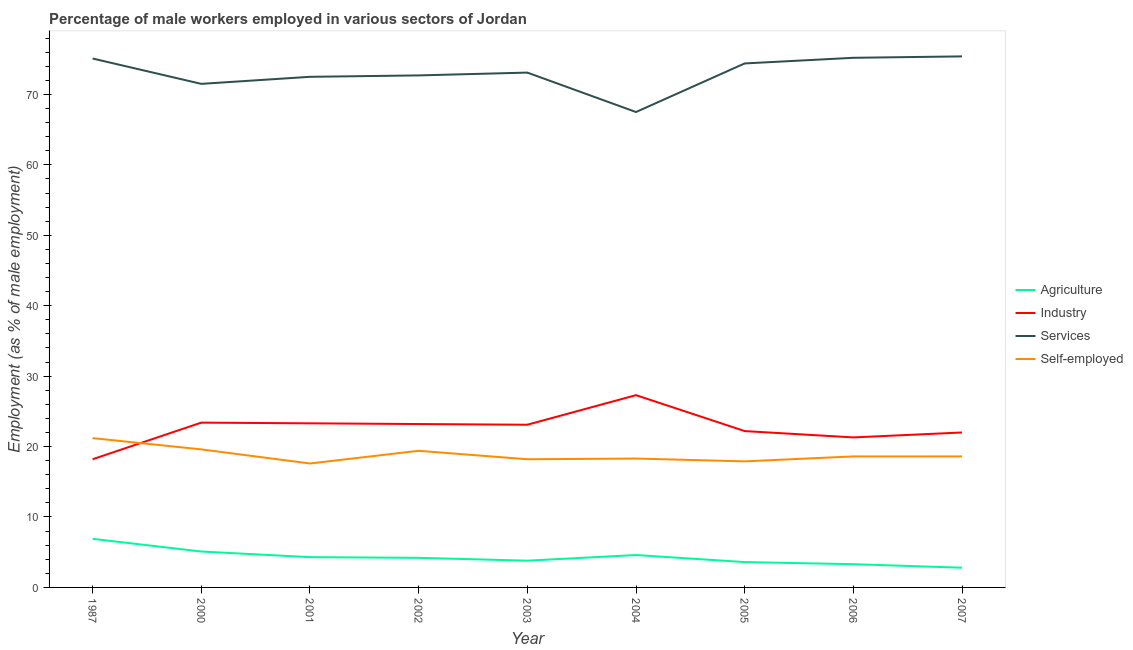How many different coloured lines are there?
Provide a short and direct response. 4. Does the line corresponding to percentage of male workers in industry intersect with the line corresponding to percentage of male workers in agriculture?
Provide a short and direct response. No. What is the percentage of male workers in services in 2000?
Ensure brevity in your answer.  71.5. Across all years, what is the maximum percentage of male workers in services?
Give a very brief answer. 75.4. Across all years, what is the minimum percentage of male workers in agriculture?
Keep it short and to the point. 2.8. In which year was the percentage of male workers in industry maximum?
Your answer should be very brief. 2004. What is the total percentage of male workers in agriculture in the graph?
Your answer should be very brief. 38.6. What is the difference between the percentage of self employed male workers in 2002 and that in 2007?
Keep it short and to the point. 0.8. What is the difference between the percentage of male workers in agriculture in 2002 and the percentage of male workers in industry in 2004?
Provide a succinct answer. -23.1. What is the average percentage of male workers in industry per year?
Make the answer very short. 22.67. In the year 2005, what is the difference between the percentage of male workers in industry and percentage of male workers in services?
Provide a short and direct response. -52.2. In how many years, is the percentage of self employed male workers greater than 72 %?
Ensure brevity in your answer.  0. What is the ratio of the percentage of male workers in agriculture in 2003 to that in 2004?
Your answer should be compact. 0.83. Is the difference between the percentage of self employed male workers in 1987 and 2000 greater than the difference between the percentage of male workers in agriculture in 1987 and 2000?
Provide a short and direct response. No. What is the difference between the highest and the second highest percentage of male workers in industry?
Your answer should be compact. 3.9. What is the difference between the highest and the lowest percentage of male workers in industry?
Your answer should be very brief. 9.1. Is it the case that in every year, the sum of the percentage of male workers in agriculture and percentage of self employed male workers is greater than the sum of percentage of male workers in services and percentage of male workers in industry?
Your answer should be compact. Yes. How many years are there in the graph?
Your answer should be very brief. 9. Are the values on the major ticks of Y-axis written in scientific E-notation?
Make the answer very short. No. Does the graph contain any zero values?
Provide a short and direct response. No. Does the graph contain grids?
Make the answer very short. No. How many legend labels are there?
Offer a terse response. 4. How are the legend labels stacked?
Provide a short and direct response. Vertical. What is the title of the graph?
Make the answer very short. Percentage of male workers employed in various sectors of Jordan. What is the label or title of the Y-axis?
Ensure brevity in your answer.  Employment (as % of male employment). What is the Employment (as % of male employment) in Agriculture in 1987?
Offer a very short reply. 6.9. What is the Employment (as % of male employment) of Industry in 1987?
Make the answer very short. 18.2. What is the Employment (as % of male employment) of Services in 1987?
Keep it short and to the point. 75.1. What is the Employment (as % of male employment) in Self-employed in 1987?
Your answer should be very brief. 21.2. What is the Employment (as % of male employment) of Agriculture in 2000?
Offer a terse response. 5.1. What is the Employment (as % of male employment) in Industry in 2000?
Your answer should be compact. 23.4. What is the Employment (as % of male employment) in Services in 2000?
Offer a terse response. 71.5. What is the Employment (as % of male employment) of Self-employed in 2000?
Make the answer very short. 19.6. What is the Employment (as % of male employment) in Agriculture in 2001?
Provide a succinct answer. 4.3. What is the Employment (as % of male employment) in Industry in 2001?
Make the answer very short. 23.3. What is the Employment (as % of male employment) of Services in 2001?
Offer a very short reply. 72.5. What is the Employment (as % of male employment) in Self-employed in 2001?
Make the answer very short. 17.6. What is the Employment (as % of male employment) of Agriculture in 2002?
Make the answer very short. 4.2. What is the Employment (as % of male employment) of Industry in 2002?
Your response must be concise. 23.2. What is the Employment (as % of male employment) in Services in 2002?
Give a very brief answer. 72.7. What is the Employment (as % of male employment) of Self-employed in 2002?
Your answer should be very brief. 19.4. What is the Employment (as % of male employment) in Agriculture in 2003?
Offer a terse response. 3.8. What is the Employment (as % of male employment) of Industry in 2003?
Provide a succinct answer. 23.1. What is the Employment (as % of male employment) in Services in 2003?
Make the answer very short. 73.1. What is the Employment (as % of male employment) in Self-employed in 2003?
Keep it short and to the point. 18.2. What is the Employment (as % of male employment) in Agriculture in 2004?
Your answer should be compact. 4.6. What is the Employment (as % of male employment) in Industry in 2004?
Your answer should be compact. 27.3. What is the Employment (as % of male employment) of Services in 2004?
Ensure brevity in your answer.  67.5. What is the Employment (as % of male employment) of Self-employed in 2004?
Give a very brief answer. 18.3. What is the Employment (as % of male employment) of Agriculture in 2005?
Give a very brief answer. 3.6. What is the Employment (as % of male employment) in Industry in 2005?
Give a very brief answer. 22.2. What is the Employment (as % of male employment) of Services in 2005?
Keep it short and to the point. 74.4. What is the Employment (as % of male employment) in Self-employed in 2005?
Provide a short and direct response. 17.9. What is the Employment (as % of male employment) of Agriculture in 2006?
Ensure brevity in your answer.  3.3. What is the Employment (as % of male employment) in Industry in 2006?
Offer a terse response. 21.3. What is the Employment (as % of male employment) of Services in 2006?
Your response must be concise. 75.2. What is the Employment (as % of male employment) of Self-employed in 2006?
Make the answer very short. 18.6. What is the Employment (as % of male employment) in Agriculture in 2007?
Your answer should be very brief. 2.8. What is the Employment (as % of male employment) in Industry in 2007?
Offer a terse response. 22. What is the Employment (as % of male employment) of Services in 2007?
Your answer should be very brief. 75.4. What is the Employment (as % of male employment) of Self-employed in 2007?
Your response must be concise. 18.6. Across all years, what is the maximum Employment (as % of male employment) in Agriculture?
Your answer should be very brief. 6.9. Across all years, what is the maximum Employment (as % of male employment) in Industry?
Your answer should be compact. 27.3. Across all years, what is the maximum Employment (as % of male employment) of Services?
Your answer should be very brief. 75.4. Across all years, what is the maximum Employment (as % of male employment) in Self-employed?
Ensure brevity in your answer.  21.2. Across all years, what is the minimum Employment (as % of male employment) of Agriculture?
Offer a very short reply. 2.8. Across all years, what is the minimum Employment (as % of male employment) of Industry?
Your answer should be very brief. 18.2. Across all years, what is the minimum Employment (as % of male employment) in Services?
Offer a very short reply. 67.5. Across all years, what is the minimum Employment (as % of male employment) in Self-employed?
Offer a terse response. 17.6. What is the total Employment (as % of male employment) of Agriculture in the graph?
Ensure brevity in your answer.  38.6. What is the total Employment (as % of male employment) of Industry in the graph?
Your answer should be very brief. 204. What is the total Employment (as % of male employment) of Services in the graph?
Make the answer very short. 657.4. What is the total Employment (as % of male employment) in Self-employed in the graph?
Make the answer very short. 169.4. What is the difference between the Employment (as % of male employment) of Industry in 1987 and that in 2000?
Offer a very short reply. -5.2. What is the difference between the Employment (as % of male employment) in Agriculture in 1987 and that in 2001?
Make the answer very short. 2.6. What is the difference between the Employment (as % of male employment) in Self-employed in 1987 and that in 2001?
Your answer should be very brief. 3.6. What is the difference between the Employment (as % of male employment) of Agriculture in 1987 and that in 2002?
Your response must be concise. 2.7. What is the difference between the Employment (as % of male employment) in Services in 1987 and that in 2002?
Offer a terse response. 2.4. What is the difference between the Employment (as % of male employment) in Self-employed in 1987 and that in 2002?
Keep it short and to the point. 1.8. What is the difference between the Employment (as % of male employment) in Agriculture in 1987 and that in 2003?
Offer a very short reply. 3.1. What is the difference between the Employment (as % of male employment) in Industry in 1987 and that in 2003?
Offer a very short reply. -4.9. What is the difference between the Employment (as % of male employment) of Self-employed in 1987 and that in 2003?
Ensure brevity in your answer.  3. What is the difference between the Employment (as % of male employment) of Industry in 1987 and that in 2004?
Keep it short and to the point. -9.1. What is the difference between the Employment (as % of male employment) in Services in 1987 and that in 2005?
Your answer should be compact. 0.7. What is the difference between the Employment (as % of male employment) in Self-employed in 1987 and that in 2005?
Offer a very short reply. 3.3. What is the difference between the Employment (as % of male employment) in Agriculture in 1987 and that in 2006?
Ensure brevity in your answer.  3.6. What is the difference between the Employment (as % of male employment) in Industry in 1987 and that in 2006?
Keep it short and to the point. -3.1. What is the difference between the Employment (as % of male employment) in Self-employed in 1987 and that in 2006?
Keep it short and to the point. 2.6. What is the difference between the Employment (as % of male employment) in Agriculture in 1987 and that in 2007?
Offer a terse response. 4.1. What is the difference between the Employment (as % of male employment) of Industry in 1987 and that in 2007?
Offer a very short reply. -3.8. What is the difference between the Employment (as % of male employment) of Services in 1987 and that in 2007?
Provide a short and direct response. -0.3. What is the difference between the Employment (as % of male employment) in Self-employed in 1987 and that in 2007?
Ensure brevity in your answer.  2.6. What is the difference between the Employment (as % of male employment) in Agriculture in 2000 and that in 2001?
Your answer should be compact. 0.8. What is the difference between the Employment (as % of male employment) in Services in 2000 and that in 2001?
Your response must be concise. -1. What is the difference between the Employment (as % of male employment) in Self-employed in 2000 and that in 2001?
Your answer should be compact. 2. What is the difference between the Employment (as % of male employment) in Agriculture in 2000 and that in 2002?
Offer a very short reply. 0.9. What is the difference between the Employment (as % of male employment) in Self-employed in 2000 and that in 2002?
Provide a short and direct response. 0.2. What is the difference between the Employment (as % of male employment) of Agriculture in 2000 and that in 2003?
Your response must be concise. 1.3. What is the difference between the Employment (as % of male employment) in Industry in 2000 and that in 2003?
Your response must be concise. 0.3. What is the difference between the Employment (as % of male employment) of Self-employed in 2000 and that in 2003?
Your answer should be very brief. 1.4. What is the difference between the Employment (as % of male employment) in Self-employed in 2000 and that in 2004?
Provide a succinct answer. 1.3. What is the difference between the Employment (as % of male employment) of Agriculture in 2000 and that in 2005?
Provide a succinct answer. 1.5. What is the difference between the Employment (as % of male employment) of Self-employed in 2000 and that in 2005?
Your response must be concise. 1.7. What is the difference between the Employment (as % of male employment) of Agriculture in 2000 and that in 2006?
Your answer should be compact. 1.8. What is the difference between the Employment (as % of male employment) in Agriculture in 2000 and that in 2007?
Your response must be concise. 2.3. What is the difference between the Employment (as % of male employment) of Industry in 2000 and that in 2007?
Provide a succinct answer. 1.4. What is the difference between the Employment (as % of male employment) in Services in 2000 and that in 2007?
Keep it short and to the point. -3.9. What is the difference between the Employment (as % of male employment) in Self-employed in 2000 and that in 2007?
Make the answer very short. 1. What is the difference between the Employment (as % of male employment) in Agriculture in 2001 and that in 2002?
Your answer should be very brief. 0.1. What is the difference between the Employment (as % of male employment) in Industry in 2001 and that in 2002?
Your answer should be very brief. 0.1. What is the difference between the Employment (as % of male employment) in Services in 2001 and that in 2002?
Make the answer very short. -0.2. What is the difference between the Employment (as % of male employment) in Self-employed in 2001 and that in 2002?
Offer a terse response. -1.8. What is the difference between the Employment (as % of male employment) of Industry in 2001 and that in 2003?
Provide a succinct answer. 0.2. What is the difference between the Employment (as % of male employment) in Self-employed in 2001 and that in 2003?
Your response must be concise. -0.6. What is the difference between the Employment (as % of male employment) in Agriculture in 2001 and that in 2004?
Provide a succinct answer. -0.3. What is the difference between the Employment (as % of male employment) in Services in 2001 and that in 2004?
Offer a terse response. 5. What is the difference between the Employment (as % of male employment) in Self-employed in 2001 and that in 2004?
Ensure brevity in your answer.  -0.7. What is the difference between the Employment (as % of male employment) of Agriculture in 2001 and that in 2006?
Ensure brevity in your answer.  1. What is the difference between the Employment (as % of male employment) in Services in 2001 and that in 2006?
Offer a terse response. -2.7. What is the difference between the Employment (as % of male employment) in Self-employed in 2001 and that in 2006?
Provide a short and direct response. -1. What is the difference between the Employment (as % of male employment) in Agriculture in 2001 and that in 2007?
Ensure brevity in your answer.  1.5. What is the difference between the Employment (as % of male employment) of Industry in 2001 and that in 2007?
Provide a short and direct response. 1.3. What is the difference between the Employment (as % of male employment) in Agriculture in 2002 and that in 2003?
Offer a very short reply. 0.4. What is the difference between the Employment (as % of male employment) of Services in 2002 and that in 2004?
Offer a very short reply. 5.2. What is the difference between the Employment (as % of male employment) in Self-employed in 2002 and that in 2004?
Keep it short and to the point. 1.1. What is the difference between the Employment (as % of male employment) of Industry in 2002 and that in 2005?
Your answer should be very brief. 1. What is the difference between the Employment (as % of male employment) of Self-employed in 2002 and that in 2005?
Make the answer very short. 1.5. What is the difference between the Employment (as % of male employment) of Agriculture in 2002 and that in 2006?
Your response must be concise. 0.9. What is the difference between the Employment (as % of male employment) of Industry in 2002 and that in 2006?
Your answer should be very brief. 1.9. What is the difference between the Employment (as % of male employment) in Services in 2002 and that in 2006?
Give a very brief answer. -2.5. What is the difference between the Employment (as % of male employment) in Self-employed in 2002 and that in 2006?
Keep it short and to the point. 0.8. What is the difference between the Employment (as % of male employment) of Agriculture in 2002 and that in 2007?
Your response must be concise. 1.4. What is the difference between the Employment (as % of male employment) of Industry in 2003 and that in 2005?
Your answer should be very brief. 0.9. What is the difference between the Employment (as % of male employment) of Services in 2003 and that in 2005?
Provide a short and direct response. -1.3. What is the difference between the Employment (as % of male employment) of Self-employed in 2003 and that in 2005?
Offer a very short reply. 0.3. What is the difference between the Employment (as % of male employment) in Industry in 2003 and that in 2006?
Offer a terse response. 1.8. What is the difference between the Employment (as % of male employment) of Self-employed in 2003 and that in 2007?
Provide a short and direct response. -0.4. What is the difference between the Employment (as % of male employment) of Agriculture in 2004 and that in 2005?
Keep it short and to the point. 1. What is the difference between the Employment (as % of male employment) of Industry in 2004 and that in 2005?
Make the answer very short. 5.1. What is the difference between the Employment (as % of male employment) of Services in 2004 and that in 2005?
Offer a terse response. -6.9. What is the difference between the Employment (as % of male employment) in Self-employed in 2004 and that in 2005?
Keep it short and to the point. 0.4. What is the difference between the Employment (as % of male employment) in Agriculture in 2004 and that in 2006?
Offer a very short reply. 1.3. What is the difference between the Employment (as % of male employment) of Industry in 2004 and that in 2006?
Offer a terse response. 6. What is the difference between the Employment (as % of male employment) in Services in 2004 and that in 2006?
Ensure brevity in your answer.  -7.7. What is the difference between the Employment (as % of male employment) of Self-employed in 2004 and that in 2006?
Offer a very short reply. -0.3. What is the difference between the Employment (as % of male employment) of Industry in 2004 and that in 2007?
Your answer should be compact. 5.3. What is the difference between the Employment (as % of male employment) of Services in 2004 and that in 2007?
Offer a terse response. -7.9. What is the difference between the Employment (as % of male employment) in Self-employed in 2004 and that in 2007?
Provide a short and direct response. -0.3. What is the difference between the Employment (as % of male employment) in Agriculture in 2005 and that in 2006?
Your answer should be very brief. 0.3. What is the difference between the Employment (as % of male employment) of Self-employed in 2005 and that in 2006?
Your answer should be very brief. -0.7. What is the difference between the Employment (as % of male employment) in Agriculture in 2005 and that in 2007?
Ensure brevity in your answer.  0.8. What is the difference between the Employment (as % of male employment) in Services in 2005 and that in 2007?
Your answer should be very brief. -1. What is the difference between the Employment (as % of male employment) of Self-employed in 2006 and that in 2007?
Provide a succinct answer. 0. What is the difference between the Employment (as % of male employment) in Agriculture in 1987 and the Employment (as % of male employment) in Industry in 2000?
Give a very brief answer. -16.5. What is the difference between the Employment (as % of male employment) in Agriculture in 1987 and the Employment (as % of male employment) in Services in 2000?
Make the answer very short. -64.6. What is the difference between the Employment (as % of male employment) of Industry in 1987 and the Employment (as % of male employment) of Services in 2000?
Offer a terse response. -53.3. What is the difference between the Employment (as % of male employment) of Industry in 1987 and the Employment (as % of male employment) of Self-employed in 2000?
Offer a terse response. -1.4. What is the difference between the Employment (as % of male employment) in Services in 1987 and the Employment (as % of male employment) in Self-employed in 2000?
Ensure brevity in your answer.  55.5. What is the difference between the Employment (as % of male employment) of Agriculture in 1987 and the Employment (as % of male employment) of Industry in 2001?
Offer a very short reply. -16.4. What is the difference between the Employment (as % of male employment) of Agriculture in 1987 and the Employment (as % of male employment) of Services in 2001?
Your response must be concise. -65.6. What is the difference between the Employment (as % of male employment) in Industry in 1987 and the Employment (as % of male employment) in Services in 2001?
Make the answer very short. -54.3. What is the difference between the Employment (as % of male employment) of Industry in 1987 and the Employment (as % of male employment) of Self-employed in 2001?
Provide a succinct answer. 0.6. What is the difference between the Employment (as % of male employment) of Services in 1987 and the Employment (as % of male employment) of Self-employed in 2001?
Give a very brief answer. 57.5. What is the difference between the Employment (as % of male employment) of Agriculture in 1987 and the Employment (as % of male employment) of Industry in 2002?
Your response must be concise. -16.3. What is the difference between the Employment (as % of male employment) of Agriculture in 1987 and the Employment (as % of male employment) of Services in 2002?
Offer a very short reply. -65.8. What is the difference between the Employment (as % of male employment) of Industry in 1987 and the Employment (as % of male employment) of Services in 2002?
Provide a succinct answer. -54.5. What is the difference between the Employment (as % of male employment) of Services in 1987 and the Employment (as % of male employment) of Self-employed in 2002?
Provide a short and direct response. 55.7. What is the difference between the Employment (as % of male employment) of Agriculture in 1987 and the Employment (as % of male employment) of Industry in 2003?
Your answer should be compact. -16.2. What is the difference between the Employment (as % of male employment) in Agriculture in 1987 and the Employment (as % of male employment) in Services in 2003?
Offer a terse response. -66.2. What is the difference between the Employment (as % of male employment) in Industry in 1987 and the Employment (as % of male employment) in Services in 2003?
Offer a terse response. -54.9. What is the difference between the Employment (as % of male employment) of Services in 1987 and the Employment (as % of male employment) of Self-employed in 2003?
Keep it short and to the point. 56.9. What is the difference between the Employment (as % of male employment) in Agriculture in 1987 and the Employment (as % of male employment) in Industry in 2004?
Give a very brief answer. -20.4. What is the difference between the Employment (as % of male employment) of Agriculture in 1987 and the Employment (as % of male employment) of Services in 2004?
Offer a terse response. -60.6. What is the difference between the Employment (as % of male employment) in Agriculture in 1987 and the Employment (as % of male employment) in Self-employed in 2004?
Keep it short and to the point. -11.4. What is the difference between the Employment (as % of male employment) of Industry in 1987 and the Employment (as % of male employment) of Services in 2004?
Provide a short and direct response. -49.3. What is the difference between the Employment (as % of male employment) in Services in 1987 and the Employment (as % of male employment) in Self-employed in 2004?
Provide a short and direct response. 56.8. What is the difference between the Employment (as % of male employment) in Agriculture in 1987 and the Employment (as % of male employment) in Industry in 2005?
Give a very brief answer. -15.3. What is the difference between the Employment (as % of male employment) of Agriculture in 1987 and the Employment (as % of male employment) of Services in 2005?
Ensure brevity in your answer.  -67.5. What is the difference between the Employment (as % of male employment) of Industry in 1987 and the Employment (as % of male employment) of Services in 2005?
Provide a short and direct response. -56.2. What is the difference between the Employment (as % of male employment) of Services in 1987 and the Employment (as % of male employment) of Self-employed in 2005?
Make the answer very short. 57.2. What is the difference between the Employment (as % of male employment) of Agriculture in 1987 and the Employment (as % of male employment) of Industry in 2006?
Provide a succinct answer. -14.4. What is the difference between the Employment (as % of male employment) in Agriculture in 1987 and the Employment (as % of male employment) in Services in 2006?
Your response must be concise. -68.3. What is the difference between the Employment (as % of male employment) in Agriculture in 1987 and the Employment (as % of male employment) in Self-employed in 2006?
Make the answer very short. -11.7. What is the difference between the Employment (as % of male employment) in Industry in 1987 and the Employment (as % of male employment) in Services in 2006?
Offer a terse response. -57. What is the difference between the Employment (as % of male employment) of Services in 1987 and the Employment (as % of male employment) of Self-employed in 2006?
Make the answer very short. 56.5. What is the difference between the Employment (as % of male employment) of Agriculture in 1987 and the Employment (as % of male employment) of Industry in 2007?
Provide a short and direct response. -15.1. What is the difference between the Employment (as % of male employment) in Agriculture in 1987 and the Employment (as % of male employment) in Services in 2007?
Your answer should be compact. -68.5. What is the difference between the Employment (as % of male employment) in Industry in 1987 and the Employment (as % of male employment) in Services in 2007?
Give a very brief answer. -57.2. What is the difference between the Employment (as % of male employment) of Services in 1987 and the Employment (as % of male employment) of Self-employed in 2007?
Give a very brief answer. 56.5. What is the difference between the Employment (as % of male employment) of Agriculture in 2000 and the Employment (as % of male employment) of Industry in 2001?
Offer a very short reply. -18.2. What is the difference between the Employment (as % of male employment) in Agriculture in 2000 and the Employment (as % of male employment) in Services in 2001?
Offer a terse response. -67.4. What is the difference between the Employment (as % of male employment) in Agriculture in 2000 and the Employment (as % of male employment) in Self-employed in 2001?
Your answer should be very brief. -12.5. What is the difference between the Employment (as % of male employment) in Industry in 2000 and the Employment (as % of male employment) in Services in 2001?
Your answer should be very brief. -49.1. What is the difference between the Employment (as % of male employment) of Industry in 2000 and the Employment (as % of male employment) of Self-employed in 2001?
Your answer should be compact. 5.8. What is the difference between the Employment (as % of male employment) of Services in 2000 and the Employment (as % of male employment) of Self-employed in 2001?
Keep it short and to the point. 53.9. What is the difference between the Employment (as % of male employment) in Agriculture in 2000 and the Employment (as % of male employment) in Industry in 2002?
Your answer should be very brief. -18.1. What is the difference between the Employment (as % of male employment) of Agriculture in 2000 and the Employment (as % of male employment) of Services in 2002?
Give a very brief answer. -67.6. What is the difference between the Employment (as % of male employment) in Agriculture in 2000 and the Employment (as % of male employment) in Self-employed in 2002?
Keep it short and to the point. -14.3. What is the difference between the Employment (as % of male employment) of Industry in 2000 and the Employment (as % of male employment) of Services in 2002?
Provide a short and direct response. -49.3. What is the difference between the Employment (as % of male employment) in Services in 2000 and the Employment (as % of male employment) in Self-employed in 2002?
Provide a short and direct response. 52.1. What is the difference between the Employment (as % of male employment) of Agriculture in 2000 and the Employment (as % of male employment) of Services in 2003?
Keep it short and to the point. -68. What is the difference between the Employment (as % of male employment) in Industry in 2000 and the Employment (as % of male employment) in Services in 2003?
Your response must be concise. -49.7. What is the difference between the Employment (as % of male employment) in Industry in 2000 and the Employment (as % of male employment) in Self-employed in 2003?
Your answer should be very brief. 5.2. What is the difference between the Employment (as % of male employment) of Services in 2000 and the Employment (as % of male employment) of Self-employed in 2003?
Keep it short and to the point. 53.3. What is the difference between the Employment (as % of male employment) of Agriculture in 2000 and the Employment (as % of male employment) of Industry in 2004?
Your answer should be very brief. -22.2. What is the difference between the Employment (as % of male employment) of Agriculture in 2000 and the Employment (as % of male employment) of Services in 2004?
Offer a terse response. -62.4. What is the difference between the Employment (as % of male employment) in Industry in 2000 and the Employment (as % of male employment) in Services in 2004?
Offer a terse response. -44.1. What is the difference between the Employment (as % of male employment) in Industry in 2000 and the Employment (as % of male employment) in Self-employed in 2004?
Keep it short and to the point. 5.1. What is the difference between the Employment (as % of male employment) of Services in 2000 and the Employment (as % of male employment) of Self-employed in 2004?
Your response must be concise. 53.2. What is the difference between the Employment (as % of male employment) of Agriculture in 2000 and the Employment (as % of male employment) of Industry in 2005?
Offer a very short reply. -17.1. What is the difference between the Employment (as % of male employment) in Agriculture in 2000 and the Employment (as % of male employment) in Services in 2005?
Offer a terse response. -69.3. What is the difference between the Employment (as % of male employment) in Agriculture in 2000 and the Employment (as % of male employment) in Self-employed in 2005?
Your response must be concise. -12.8. What is the difference between the Employment (as % of male employment) in Industry in 2000 and the Employment (as % of male employment) in Services in 2005?
Your response must be concise. -51. What is the difference between the Employment (as % of male employment) in Industry in 2000 and the Employment (as % of male employment) in Self-employed in 2005?
Give a very brief answer. 5.5. What is the difference between the Employment (as % of male employment) in Services in 2000 and the Employment (as % of male employment) in Self-employed in 2005?
Your response must be concise. 53.6. What is the difference between the Employment (as % of male employment) of Agriculture in 2000 and the Employment (as % of male employment) of Industry in 2006?
Keep it short and to the point. -16.2. What is the difference between the Employment (as % of male employment) of Agriculture in 2000 and the Employment (as % of male employment) of Services in 2006?
Offer a terse response. -70.1. What is the difference between the Employment (as % of male employment) in Industry in 2000 and the Employment (as % of male employment) in Services in 2006?
Ensure brevity in your answer.  -51.8. What is the difference between the Employment (as % of male employment) in Services in 2000 and the Employment (as % of male employment) in Self-employed in 2006?
Ensure brevity in your answer.  52.9. What is the difference between the Employment (as % of male employment) of Agriculture in 2000 and the Employment (as % of male employment) of Industry in 2007?
Offer a very short reply. -16.9. What is the difference between the Employment (as % of male employment) in Agriculture in 2000 and the Employment (as % of male employment) in Services in 2007?
Your answer should be compact. -70.3. What is the difference between the Employment (as % of male employment) in Agriculture in 2000 and the Employment (as % of male employment) in Self-employed in 2007?
Provide a short and direct response. -13.5. What is the difference between the Employment (as % of male employment) in Industry in 2000 and the Employment (as % of male employment) in Services in 2007?
Provide a short and direct response. -52. What is the difference between the Employment (as % of male employment) in Services in 2000 and the Employment (as % of male employment) in Self-employed in 2007?
Provide a succinct answer. 52.9. What is the difference between the Employment (as % of male employment) in Agriculture in 2001 and the Employment (as % of male employment) in Industry in 2002?
Keep it short and to the point. -18.9. What is the difference between the Employment (as % of male employment) of Agriculture in 2001 and the Employment (as % of male employment) of Services in 2002?
Ensure brevity in your answer.  -68.4. What is the difference between the Employment (as % of male employment) of Agriculture in 2001 and the Employment (as % of male employment) of Self-employed in 2002?
Offer a terse response. -15.1. What is the difference between the Employment (as % of male employment) of Industry in 2001 and the Employment (as % of male employment) of Services in 2002?
Keep it short and to the point. -49.4. What is the difference between the Employment (as % of male employment) of Industry in 2001 and the Employment (as % of male employment) of Self-employed in 2002?
Offer a terse response. 3.9. What is the difference between the Employment (as % of male employment) in Services in 2001 and the Employment (as % of male employment) in Self-employed in 2002?
Provide a short and direct response. 53.1. What is the difference between the Employment (as % of male employment) in Agriculture in 2001 and the Employment (as % of male employment) in Industry in 2003?
Provide a succinct answer. -18.8. What is the difference between the Employment (as % of male employment) of Agriculture in 2001 and the Employment (as % of male employment) of Services in 2003?
Your answer should be very brief. -68.8. What is the difference between the Employment (as % of male employment) in Agriculture in 2001 and the Employment (as % of male employment) in Self-employed in 2003?
Make the answer very short. -13.9. What is the difference between the Employment (as % of male employment) in Industry in 2001 and the Employment (as % of male employment) in Services in 2003?
Give a very brief answer. -49.8. What is the difference between the Employment (as % of male employment) in Services in 2001 and the Employment (as % of male employment) in Self-employed in 2003?
Your answer should be compact. 54.3. What is the difference between the Employment (as % of male employment) of Agriculture in 2001 and the Employment (as % of male employment) of Industry in 2004?
Your response must be concise. -23. What is the difference between the Employment (as % of male employment) of Agriculture in 2001 and the Employment (as % of male employment) of Services in 2004?
Provide a succinct answer. -63.2. What is the difference between the Employment (as % of male employment) of Agriculture in 2001 and the Employment (as % of male employment) of Self-employed in 2004?
Offer a very short reply. -14. What is the difference between the Employment (as % of male employment) in Industry in 2001 and the Employment (as % of male employment) in Services in 2004?
Make the answer very short. -44.2. What is the difference between the Employment (as % of male employment) of Services in 2001 and the Employment (as % of male employment) of Self-employed in 2004?
Your answer should be compact. 54.2. What is the difference between the Employment (as % of male employment) of Agriculture in 2001 and the Employment (as % of male employment) of Industry in 2005?
Ensure brevity in your answer.  -17.9. What is the difference between the Employment (as % of male employment) in Agriculture in 2001 and the Employment (as % of male employment) in Services in 2005?
Your answer should be compact. -70.1. What is the difference between the Employment (as % of male employment) in Industry in 2001 and the Employment (as % of male employment) in Services in 2005?
Offer a terse response. -51.1. What is the difference between the Employment (as % of male employment) in Industry in 2001 and the Employment (as % of male employment) in Self-employed in 2005?
Provide a short and direct response. 5.4. What is the difference between the Employment (as % of male employment) of Services in 2001 and the Employment (as % of male employment) of Self-employed in 2005?
Your answer should be very brief. 54.6. What is the difference between the Employment (as % of male employment) of Agriculture in 2001 and the Employment (as % of male employment) of Industry in 2006?
Keep it short and to the point. -17. What is the difference between the Employment (as % of male employment) of Agriculture in 2001 and the Employment (as % of male employment) of Services in 2006?
Your answer should be very brief. -70.9. What is the difference between the Employment (as % of male employment) of Agriculture in 2001 and the Employment (as % of male employment) of Self-employed in 2006?
Offer a terse response. -14.3. What is the difference between the Employment (as % of male employment) in Industry in 2001 and the Employment (as % of male employment) in Services in 2006?
Your response must be concise. -51.9. What is the difference between the Employment (as % of male employment) of Services in 2001 and the Employment (as % of male employment) of Self-employed in 2006?
Offer a very short reply. 53.9. What is the difference between the Employment (as % of male employment) in Agriculture in 2001 and the Employment (as % of male employment) in Industry in 2007?
Your answer should be very brief. -17.7. What is the difference between the Employment (as % of male employment) in Agriculture in 2001 and the Employment (as % of male employment) in Services in 2007?
Make the answer very short. -71.1. What is the difference between the Employment (as % of male employment) of Agriculture in 2001 and the Employment (as % of male employment) of Self-employed in 2007?
Offer a very short reply. -14.3. What is the difference between the Employment (as % of male employment) of Industry in 2001 and the Employment (as % of male employment) of Services in 2007?
Ensure brevity in your answer.  -52.1. What is the difference between the Employment (as % of male employment) of Industry in 2001 and the Employment (as % of male employment) of Self-employed in 2007?
Provide a short and direct response. 4.7. What is the difference between the Employment (as % of male employment) of Services in 2001 and the Employment (as % of male employment) of Self-employed in 2007?
Keep it short and to the point. 53.9. What is the difference between the Employment (as % of male employment) of Agriculture in 2002 and the Employment (as % of male employment) of Industry in 2003?
Make the answer very short. -18.9. What is the difference between the Employment (as % of male employment) in Agriculture in 2002 and the Employment (as % of male employment) in Services in 2003?
Provide a short and direct response. -68.9. What is the difference between the Employment (as % of male employment) of Industry in 2002 and the Employment (as % of male employment) of Services in 2003?
Your answer should be compact. -49.9. What is the difference between the Employment (as % of male employment) of Services in 2002 and the Employment (as % of male employment) of Self-employed in 2003?
Ensure brevity in your answer.  54.5. What is the difference between the Employment (as % of male employment) of Agriculture in 2002 and the Employment (as % of male employment) of Industry in 2004?
Make the answer very short. -23.1. What is the difference between the Employment (as % of male employment) in Agriculture in 2002 and the Employment (as % of male employment) in Services in 2004?
Offer a terse response. -63.3. What is the difference between the Employment (as % of male employment) in Agriculture in 2002 and the Employment (as % of male employment) in Self-employed in 2004?
Ensure brevity in your answer.  -14.1. What is the difference between the Employment (as % of male employment) in Industry in 2002 and the Employment (as % of male employment) in Services in 2004?
Your answer should be very brief. -44.3. What is the difference between the Employment (as % of male employment) in Industry in 2002 and the Employment (as % of male employment) in Self-employed in 2004?
Keep it short and to the point. 4.9. What is the difference between the Employment (as % of male employment) in Services in 2002 and the Employment (as % of male employment) in Self-employed in 2004?
Make the answer very short. 54.4. What is the difference between the Employment (as % of male employment) of Agriculture in 2002 and the Employment (as % of male employment) of Services in 2005?
Offer a terse response. -70.2. What is the difference between the Employment (as % of male employment) in Agriculture in 2002 and the Employment (as % of male employment) in Self-employed in 2005?
Your answer should be compact. -13.7. What is the difference between the Employment (as % of male employment) of Industry in 2002 and the Employment (as % of male employment) of Services in 2005?
Keep it short and to the point. -51.2. What is the difference between the Employment (as % of male employment) in Industry in 2002 and the Employment (as % of male employment) in Self-employed in 2005?
Your answer should be compact. 5.3. What is the difference between the Employment (as % of male employment) of Services in 2002 and the Employment (as % of male employment) of Self-employed in 2005?
Your answer should be compact. 54.8. What is the difference between the Employment (as % of male employment) of Agriculture in 2002 and the Employment (as % of male employment) of Industry in 2006?
Keep it short and to the point. -17.1. What is the difference between the Employment (as % of male employment) of Agriculture in 2002 and the Employment (as % of male employment) of Services in 2006?
Give a very brief answer. -71. What is the difference between the Employment (as % of male employment) of Agriculture in 2002 and the Employment (as % of male employment) of Self-employed in 2006?
Keep it short and to the point. -14.4. What is the difference between the Employment (as % of male employment) of Industry in 2002 and the Employment (as % of male employment) of Services in 2006?
Your answer should be compact. -52. What is the difference between the Employment (as % of male employment) of Industry in 2002 and the Employment (as % of male employment) of Self-employed in 2006?
Give a very brief answer. 4.6. What is the difference between the Employment (as % of male employment) of Services in 2002 and the Employment (as % of male employment) of Self-employed in 2006?
Give a very brief answer. 54.1. What is the difference between the Employment (as % of male employment) in Agriculture in 2002 and the Employment (as % of male employment) in Industry in 2007?
Offer a terse response. -17.8. What is the difference between the Employment (as % of male employment) in Agriculture in 2002 and the Employment (as % of male employment) in Services in 2007?
Give a very brief answer. -71.2. What is the difference between the Employment (as % of male employment) of Agriculture in 2002 and the Employment (as % of male employment) of Self-employed in 2007?
Ensure brevity in your answer.  -14.4. What is the difference between the Employment (as % of male employment) in Industry in 2002 and the Employment (as % of male employment) in Services in 2007?
Your response must be concise. -52.2. What is the difference between the Employment (as % of male employment) in Industry in 2002 and the Employment (as % of male employment) in Self-employed in 2007?
Your answer should be compact. 4.6. What is the difference between the Employment (as % of male employment) of Services in 2002 and the Employment (as % of male employment) of Self-employed in 2007?
Ensure brevity in your answer.  54.1. What is the difference between the Employment (as % of male employment) in Agriculture in 2003 and the Employment (as % of male employment) in Industry in 2004?
Your response must be concise. -23.5. What is the difference between the Employment (as % of male employment) in Agriculture in 2003 and the Employment (as % of male employment) in Services in 2004?
Ensure brevity in your answer.  -63.7. What is the difference between the Employment (as % of male employment) in Agriculture in 2003 and the Employment (as % of male employment) in Self-employed in 2004?
Give a very brief answer. -14.5. What is the difference between the Employment (as % of male employment) of Industry in 2003 and the Employment (as % of male employment) of Services in 2004?
Your response must be concise. -44.4. What is the difference between the Employment (as % of male employment) in Services in 2003 and the Employment (as % of male employment) in Self-employed in 2004?
Your answer should be very brief. 54.8. What is the difference between the Employment (as % of male employment) of Agriculture in 2003 and the Employment (as % of male employment) of Industry in 2005?
Your answer should be very brief. -18.4. What is the difference between the Employment (as % of male employment) in Agriculture in 2003 and the Employment (as % of male employment) in Services in 2005?
Offer a very short reply. -70.6. What is the difference between the Employment (as % of male employment) in Agriculture in 2003 and the Employment (as % of male employment) in Self-employed in 2005?
Your response must be concise. -14.1. What is the difference between the Employment (as % of male employment) of Industry in 2003 and the Employment (as % of male employment) of Services in 2005?
Provide a short and direct response. -51.3. What is the difference between the Employment (as % of male employment) of Services in 2003 and the Employment (as % of male employment) of Self-employed in 2005?
Make the answer very short. 55.2. What is the difference between the Employment (as % of male employment) in Agriculture in 2003 and the Employment (as % of male employment) in Industry in 2006?
Your answer should be compact. -17.5. What is the difference between the Employment (as % of male employment) of Agriculture in 2003 and the Employment (as % of male employment) of Services in 2006?
Provide a short and direct response. -71.4. What is the difference between the Employment (as % of male employment) in Agriculture in 2003 and the Employment (as % of male employment) in Self-employed in 2006?
Keep it short and to the point. -14.8. What is the difference between the Employment (as % of male employment) in Industry in 2003 and the Employment (as % of male employment) in Services in 2006?
Your answer should be compact. -52.1. What is the difference between the Employment (as % of male employment) of Industry in 2003 and the Employment (as % of male employment) of Self-employed in 2006?
Your answer should be very brief. 4.5. What is the difference between the Employment (as % of male employment) of Services in 2003 and the Employment (as % of male employment) of Self-employed in 2006?
Provide a succinct answer. 54.5. What is the difference between the Employment (as % of male employment) in Agriculture in 2003 and the Employment (as % of male employment) in Industry in 2007?
Make the answer very short. -18.2. What is the difference between the Employment (as % of male employment) in Agriculture in 2003 and the Employment (as % of male employment) in Services in 2007?
Offer a very short reply. -71.6. What is the difference between the Employment (as % of male employment) of Agriculture in 2003 and the Employment (as % of male employment) of Self-employed in 2007?
Provide a succinct answer. -14.8. What is the difference between the Employment (as % of male employment) of Industry in 2003 and the Employment (as % of male employment) of Services in 2007?
Provide a succinct answer. -52.3. What is the difference between the Employment (as % of male employment) of Industry in 2003 and the Employment (as % of male employment) of Self-employed in 2007?
Provide a short and direct response. 4.5. What is the difference between the Employment (as % of male employment) in Services in 2003 and the Employment (as % of male employment) in Self-employed in 2007?
Provide a short and direct response. 54.5. What is the difference between the Employment (as % of male employment) in Agriculture in 2004 and the Employment (as % of male employment) in Industry in 2005?
Your response must be concise. -17.6. What is the difference between the Employment (as % of male employment) of Agriculture in 2004 and the Employment (as % of male employment) of Services in 2005?
Your answer should be compact. -69.8. What is the difference between the Employment (as % of male employment) in Agriculture in 2004 and the Employment (as % of male employment) in Self-employed in 2005?
Give a very brief answer. -13.3. What is the difference between the Employment (as % of male employment) in Industry in 2004 and the Employment (as % of male employment) in Services in 2005?
Offer a terse response. -47.1. What is the difference between the Employment (as % of male employment) of Industry in 2004 and the Employment (as % of male employment) of Self-employed in 2005?
Ensure brevity in your answer.  9.4. What is the difference between the Employment (as % of male employment) of Services in 2004 and the Employment (as % of male employment) of Self-employed in 2005?
Offer a very short reply. 49.6. What is the difference between the Employment (as % of male employment) in Agriculture in 2004 and the Employment (as % of male employment) in Industry in 2006?
Make the answer very short. -16.7. What is the difference between the Employment (as % of male employment) of Agriculture in 2004 and the Employment (as % of male employment) of Services in 2006?
Provide a short and direct response. -70.6. What is the difference between the Employment (as % of male employment) in Industry in 2004 and the Employment (as % of male employment) in Services in 2006?
Keep it short and to the point. -47.9. What is the difference between the Employment (as % of male employment) of Industry in 2004 and the Employment (as % of male employment) of Self-employed in 2006?
Offer a terse response. 8.7. What is the difference between the Employment (as % of male employment) in Services in 2004 and the Employment (as % of male employment) in Self-employed in 2006?
Make the answer very short. 48.9. What is the difference between the Employment (as % of male employment) of Agriculture in 2004 and the Employment (as % of male employment) of Industry in 2007?
Provide a short and direct response. -17.4. What is the difference between the Employment (as % of male employment) in Agriculture in 2004 and the Employment (as % of male employment) in Services in 2007?
Provide a succinct answer. -70.8. What is the difference between the Employment (as % of male employment) of Agriculture in 2004 and the Employment (as % of male employment) of Self-employed in 2007?
Give a very brief answer. -14. What is the difference between the Employment (as % of male employment) of Industry in 2004 and the Employment (as % of male employment) of Services in 2007?
Keep it short and to the point. -48.1. What is the difference between the Employment (as % of male employment) of Industry in 2004 and the Employment (as % of male employment) of Self-employed in 2007?
Offer a terse response. 8.7. What is the difference between the Employment (as % of male employment) in Services in 2004 and the Employment (as % of male employment) in Self-employed in 2007?
Ensure brevity in your answer.  48.9. What is the difference between the Employment (as % of male employment) in Agriculture in 2005 and the Employment (as % of male employment) in Industry in 2006?
Make the answer very short. -17.7. What is the difference between the Employment (as % of male employment) in Agriculture in 2005 and the Employment (as % of male employment) in Services in 2006?
Your answer should be compact. -71.6. What is the difference between the Employment (as % of male employment) of Agriculture in 2005 and the Employment (as % of male employment) of Self-employed in 2006?
Offer a very short reply. -15. What is the difference between the Employment (as % of male employment) of Industry in 2005 and the Employment (as % of male employment) of Services in 2006?
Your answer should be very brief. -53. What is the difference between the Employment (as % of male employment) in Industry in 2005 and the Employment (as % of male employment) in Self-employed in 2006?
Keep it short and to the point. 3.6. What is the difference between the Employment (as % of male employment) of Services in 2005 and the Employment (as % of male employment) of Self-employed in 2006?
Provide a succinct answer. 55.8. What is the difference between the Employment (as % of male employment) in Agriculture in 2005 and the Employment (as % of male employment) in Industry in 2007?
Your answer should be very brief. -18.4. What is the difference between the Employment (as % of male employment) in Agriculture in 2005 and the Employment (as % of male employment) in Services in 2007?
Give a very brief answer. -71.8. What is the difference between the Employment (as % of male employment) in Agriculture in 2005 and the Employment (as % of male employment) in Self-employed in 2007?
Keep it short and to the point. -15. What is the difference between the Employment (as % of male employment) in Industry in 2005 and the Employment (as % of male employment) in Services in 2007?
Your response must be concise. -53.2. What is the difference between the Employment (as % of male employment) of Services in 2005 and the Employment (as % of male employment) of Self-employed in 2007?
Your answer should be compact. 55.8. What is the difference between the Employment (as % of male employment) in Agriculture in 2006 and the Employment (as % of male employment) in Industry in 2007?
Offer a terse response. -18.7. What is the difference between the Employment (as % of male employment) of Agriculture in 2006 and the Employment (as % of male employment) of Services in 2007?
Keep it short and to the point. -72.1. What is the difference between the Employment (as % of male employment) in Agriculture in 2006 and the Employment (as % of male employment) in Self-employed in 2007?
Ensure brevity in your answer.  -15.3. What is the difference between the Employment (as % of male employment) of Industry in 2006 and the Employment (as % of male employment) of Services in 2007?
Offer a terse response. -54.1. What is the difference between the Employment (as % of male employment) of Industry in 2006 and the Employment (as % of male employment) of Self-employed in 2007?
Your answer should be compact. 2.7. What is the difference between the Employment (as % of male employment) of Services in 2006 and the Employment (as % of male employment) of Self-employed in 2007?
Make the answer very short. 56.6. What is the average Employment (as % of male employment) of Agriculture per year?
Your answer should be very brief. 4.29. What is the average Employment (as % of male employment) of Industry per year?
Provide a short and direct response. 22.67. What is the average Employment (as % of male employment) of Services per year?
Offer a very short reply. 73.04. What is the average Employment (as % of male employment) of Self-employed per year?
Give a very brief answer. 18.82. In the year 1987, what is the difference between the Employment (as % of male employment) of Agriculture and Employment (as % of male employment) of Industry?
Offer a terse response. -11.3. In the year 1987, what is the difference between the Employment (as % of male employment) in Agriculture and Employment (as % of male employment) in Services?
Make the answer very short. -68.2. In the year 1987, what is the difference between the Employment (as % of male employment) of Agriculture and Employment (as % of male employment) of Self-employed?
Offer a very short reply. -14.3. In the year 1987, what is the difference between the Employment (as % of male employment) in Industry and Employment (as % of male employment) in Services?
Offer a terse response. -56.9. In the year 1987, what is the difference between the Employment (as % of male employment) in Services and Employment (as % of male employment) in Self-employed?
Offer a very short reply. 53.9. In the year 2000, what is the difference between the Employment (as % of male employment) of Agriculture and Employment (as % of male employment) of Industry?
Provide a succinct answer. -18.3. In the year 2000, what is the difference between the Employment (as % of male employment) in Agriculture and Employment (as % of male employment) in Services?
Provide a short and direct response. -66.4. In the year 2000, what is the difference between the Employment (as % of male employment) of Industry and Employment (as % of male employment) of Services?
Offer a terse response. -48.1. In the year 2000, what is the difference between the Employment (as % of male employment) of Industry and Employment (as % of male employment) of Self-employed?
Provide a short and direct response. 3.8. In the year 2000, what is the difference between the Employment (as % of male employment) of Services and Employment (as % of male employment) of Self-employed?
Your answer should be very brief. 51.9. In the year 2001, what is the difference between the Employment (as % of male employment) of Agriculture and Employment (as % of male employment) of Industry?
Keep it short and to the point. -19. In the year 2001, what is the difference between the Employment (as % of male employment) in Agriculture and Employment (as % of male employment) in Services?
Give a very brief answer. -68.2. In the year 2001, what is the difference between the Employment (as % of male employment) in Industry and Employment (as % of male employment) in Services?
Provide a succinct answer. -49.2. In the year 2001, what is the difference between the Employment (as % of male employment) of Services and Employment (as % of male employment) of Self-employed?
Give a very brief answer. 54.9. In the year 2002, what is the difference between the Employment (as % of male employment) in Agriculture and Employment (as % of male employment) in Industry?
Make the answer very short. -19. In the year 2002, what is the difference between the Employment (as % of male employment) in Agriculture and Employment (as % of male employment) in Services?
Provide a short and direct response. -68.5. In the year 2002, what is the difference between the Employment (as % of male employment) in Agriculture and Employment (as % of male employment) in Self-employed?
Your answer should be compact. -15.2. In the year 2002, what is the difference between the Employment (as % of male employment) in Industry and Employment (as % of male employment) in Services?
Give a very brief answer. -49.5. In the year 2002, what is the difference between the Employment (as % of male employment) of Services and Employment (as % of male employment) of Self-employed?
Offer a very short reply. 53.3. In the year 2003, what is the difference between the Employment (as % of male employment) of Agriculture and Employment (as % of male employment) of Industry?
Offer a very short reply. -19.3. In the year 2003, what is the difference between the Employment (as % of male employment) of Agriculture and Employment (as % of male employment) of Services?
Make the answer very short. -69.3. In the year 2003, what is the difference between the Employment (as % of male employment) in Agriculture and Employment (as % of male employment) in Self-employed?
Offer a very short reply. -14.4. In the year 2003, what is the difference between the Employment (as % of male employment) of Industry and Employment (as % of male employment) of Services?
Ensure brevity in your answer.  -50. In the year 2003, what is the difference between the Employment (as % of male employment) in Services and Employment (as % of male employment) in Self-employed?
Ensure brevity in your answer.  54.9. In the year 2004, what is the difference between the Employment (as % of male employment) of Agriculture and Employment (as % of male employment) of Industry?
Offer a terse response. -22.7. In the year 2004, what is the difference between the Employment (as % of male employment) of Agriculture and Employment (as % of male employment) of Services?
Your response must be concise. -62.9. In the year 2004, what is the difference between the Employment (as % of male employment) of Agriculture and Employment (as % of male employment) of Self-employed?
Provide a succinct answer. -13.7. In the year 2004, what is the difference between the Employment (as % of male employment) in Industry and Employment (as % of male employment) in Services?
Give a very brief answer. -40.2. In the year 2004, what is the difference between the Employment (as % of male employment) of Services and Employment (as % of male employment) of Self-employed?
Your answer should be compact. 49.2. In the year 2005, what is the difference between the Employment (as % of male employment) of Agriculture and Employment (as % of male employment) of Industry?
Provide a succinct answer. -18.6. In the year 2005, what is the difference between the Employment (as % of male employment) of Agriculture and Employment (as % of male employment) of Services?
Make the answer very short. -70.8. In the year 2005, what is the difference between the Employment (as % of male employment) in Agriculture and Employment (as % of male employment) in Self-employed?
Ensure brevity in your answer.  -14.3. In the year 2005, what is the difference between the Employment (as % of male employment) in Industry and Employment (as % of male employment) in Services?
Your response must be concise. -52.2. In the year 2005, what is the difference between the Employment (as % of male employment) of Services and Employment (as % of male employment) of Self-employed?
Your answer should be compact. 56.5. In the year 2006, what is the difference between the Employment (as % of male employment) in Agriculture and Employment (as % of male employment) in Services?
Make the answer very short. -71.9. In the year 2006, what is the difference between the Employment (as % of male employment) of Agriculture and Employment (as % of male employment) of Self-employed?
Your response must be concise. -15.3. In the year 2006, what is the difference between the Employment (as % of male employment) of Industry and Employment (as % of male employment) of Services?
Give a very brief answer. -53.9. In the year 2006, what is the difference between the Employment (as % of male employment) in Industry and Employment (as % of male employment) in Self-employed?
Provide a short and direct response. 2.7. In the year 2006, what is the difference between the Employment (as % of male employment) in Services and Employment (as % of male employment) in Self-employed?
Ensure brevity in your answer.  56.6. In the year 2007, what is the difference between the Employment (as % of male employment) of Agriculture and Employment (as % of male employment) of Industry?
Offer a very short reply. -19.2. In the year 2007, what is the difference between the Employment (as % of male employment) in Agriculture and Employment (as % of male employment) in Services?
Your answer should be compact. -72.6. In the year 2007, what is the difference between the Employment (as % of male employment) in Agriculture and Employment (as % of male employment) in Self-employed?
Your answer should be very brief. -15.8. In the year 2007, what is the difference between the Employment (as % of male employment) of Industry and Employment (as % of male employment) of Services?
Provide a short and direct response. -53.4. In the year 2007, what is the difference between the Employment (as % of male employment) in Industry and Employment (as % of male employment) in Self-employed?
Provide a succinct answer. 3.4. In the year 2007, what is the difference between the Employment (as % of male employment) in Services and Employment (as % of male employment) in Self-employed?
Offer a terse response. 56.8. What is the ratio of the Employment (as % of male employment) of Agriculture in 1987 to that in 2000?
Offer a very short reply. 1.35. What is the ratio of the Employment (as % of male employment) of Industry in 1987 to that in 2000?
Offer a very short reply. 0.78. What is the ratio of the Employment (as % of male employment) in Services in 1987 to that in 2000?
Your answer should be very brief. 1.05. What is the ratio of the Employment (as % of male employment) in Self-employed in 1987 to that in 2000?
Provide a succinct answer. 1.08. What is the ratio of the Employment (as % of male employment) of Agriculture in 1987 to that in 2001?
Keep it short and to the point. 1.6. What is the ratio of the Employment (as % of male employment) in Industry in 1987 to that in 2001?
Offer a very short reply. 0.78. What is the ratio of the Employment (as % of male employment) in Services in 1987 to that in 2001?
Your response must be concise. 1.04. What is the ratio of the Employment (as % of male employment) of Self-employed in 1987 to that in 2001?
Give a very brief answer. 1.2. What is the ratio of the Employment (as % of male employment) in Agriculture in 1987 to that in 2002?
Your answer should be very brief. 1.64. What is the ratio of the Employment (as % of male employment) of Industry in 1987 to that in 2002?
Give a very brief answer. 0.78. What is the ratio of the Employment (as % of male employment) of Services in 1987 to that in 2002?
Provide a succinct answer. 1.03. What is the ratio of the Employment (as % of male employment) of Self-employed in 1987 to that in 2002?
Provide a succinct answer. 1.09. What is the ratio of the Employment (as % of male employment) in Agriculture in 1987 to that in 2003?
Offer a terse response. 1.82. What is the ratio of the Employment (as % of male employment) in Industry in 1987 to that in 2003?
Keep it short and to the point. 0.79. What is the ratio of the Employment (as % of male employment) of Services in 1987 to that in 2003?
Give a very brief answer. 1.03. What is the ratio of the Employment (as % of male employment) in Self-employed in 1987 to that in 2003?
Offer a terse response. 1.16. What is the ratio of the Employment (as % of male employment) of Services in 1987 to that in 2004?
Offer a very short reply. 1.11. What is the ratio of the Employment (as % of male employment) of Self-employed in 1987 to that in 2004?
Ensure brevity in your answer.  1.16. What is the ratio of the Employment (as % of male employment) in Agriculture in 1987 to that in 2005?
Your response must be concise. 1.92. What is the ratio of the Employment (as % of male employment) of Industry in 1987 to that in 2005?
Ensure brevity in your answer.  0.82. What is the ratio of the Employment (as % of male employment) of Services in 1987 to that in 2005?
Your response must be concise. 1.01. What is the ratio of the Employment (as % of male employment) in Self-employed in 1987 to that in 2005?
Ensure brevity in your answer.  1.18. What is the ratio of the Employment (as % of male employment) of Agriculture in 1987 to that in 2006?
Give a very brief answer. 2.09. What is the ratio of the Employment (as % of male employment) of Industry in 1987 to that in 2006?
Offer a terse response. 0.85. What is the ratio of the Employment (as % of male employment) in Self-employed in 1987 to that in 2006?
Provide a short and direct response. 1.14. What is the ratio of the Employment (as % of male employment) of Agriculture in 1987 to that in 2007?
Your answer should be very brief. 2.46. What is the ratio of the Employment (as % of male employment) of Industry in 1987 to that in 2007?
Your answer should be compact. 0.83. What is the ratio of the Employment (as % of male employment) in Services in 1987 to that in 2007?
Make the answer very short. 1. What is the ratio of the Employment (as % of male employment) of Self-employed in 1987 to that in 2007?
Offer a very short reply. 1.14. What is the ratio of the Employment (as % of male employment) of Agriculture in 2000 to that in 2001?
Provide a succinct answer. 1.19. What is the ratio of the Employment (as % of male employment) of Industry in 2000 to that in 2001?
Provide a succinct answer. 1. What is the ratio of the Employment (as % of male employment) in Services in 2000 to that in 2001?
Provide a short and direct response. 0.99. What is the ratio of the Employment (as % of male employment) in Self-employed in 2000 to that in 2001?
Ensure brevity in your answer.  1.11. What is the ratio of the Employment (as % of male employment) of Agriculture in 2000 to that in 2002?
Ensure brevity in your answer.  1.21. What is the ratio of the Employment (as % of male employment) in Industry in 2000 to that in 2002?
Your answer should be very brief. 1.01. What is the ratio of the Employment (as % of male employment) of Services in 2000 to that in 2002?
Give a very brief answer. 0.98. What is the ratio of the Employment (as % of male employment) of Self-employed in 2000 to that in 2002?
Provide a short and direct response. 1.01. What is the ratio of the Employment (as % of male employment) in Agriculture in 2000 to that in 2003?
Give a very brief answer. 1.34. What is the ratio of the Employment (as % of male employment) of Services in 2000 to that in 2003?
Your answer should be compact. 0.98. What is the ratio of the Employment (as % of male employment) in Agriculture in 2000 to that in 2004?
Your response must be concise. 1.11. What is the ratio of the Employment (as % of male employment) in Industry in 2000 to that in 2004?
Your response must be concise. 0.86. What is the ratio of the Employment (as % of male employment) of Services in 2000 to that in 2004?
Give a very brief answer. 1.06. What is the ratio of the Employment (as % of male employment) in Self-employed in 2000 to that in 2004?
Provide a succinct answer. 1.07. What is the ratio of the Employment (as % of male employment) of Agriculture in 2000 to that in 2005?
Provide a short and direct response. 1.42. What is the ratio of the Employment (as % of male employment) of Industry in 2000 to that in 2005?
Provide a succinct answer. 1.05. What is the ratio of the Employment (as % of male employment) of Services in 2000 to that in 2005?
Your answer should be very brief. 0.96. What is the ratio of the Employment (as % of male employment) of Self-employed in 2000 to that in 2005?
Your answer should be compact. 1.09. What is the ratio of the Employment (as % of male employment) of Agriculture in 2000 to that in 2006?
Your answer should be compact. 1.55. What is the ratio of the Employment (as % of male employment) in Industry in 2000 to that in 2006?
Offer a terse response. 1.1. What is the ratio of the Employment (as % of male employment) in Services in 2000 to that in 2006?
Give a very brief answer. 0.95. What is the ratio of the Employment (as % of male employment) in Self-employed in 2000 to that in 2006?
Offer a very short reply. 1.05. What is the ratio of the Employment (as % of male employment) of Agriculture in 2000 to that in 2007?
Ensure brevity in your answer.  1.82. What is the ratio of the Employment (as % of male employment) in Industry in 2000 to that in 2007?
Your response must be concise. 1.06. What is the ratio of the Employment (as % of male employment) of Services in 2000 to that in 2007?
Ensure brevity in your answer.  0.95. What is the ratio of the Employment (as % of male employment) of Self-employed in 2000 to that in 2007?
Your answer should be compact. 1.05. What is the ratio of the Employment (as % of male employment) of Agriculture in 2001 to that in 2002?
Provide a succinct answer. 1.02. What is the ratio of the Employment (as % of male employment) of Services in 2001 to that in 2002?
Make the answer very short. 1. What is the ratio of the Employment (as % of male employment) in Self-employed in 2001 to that in 2002?
Your answer should be compact. 0.91. What is the ratio of the Employment (as % of male employment) of Agriculture in 2001 to that in 2003?
Offer a terse response. 1.13. What is the ratio of the Employment (as % of male employment) in Industry in 2001 to that in 2003?
Your answer should be compact. 1.01. What is the ratio of the Employment (as % of male employment) in Services in 2001 to that in 2003?
Provide a succinct answer. 0.99. What is the ratio of the Employment (as % of male employment) in Agriculture in 2001 to that in 2004?
Your response must be concise. 0.93. What is the ratio of the Employment (as % of male employment) of Industry in 2001 to that in 2004?
Make the answer very short. 0.85. What is the ratio of the Employment (as % of male employment) in Services in 2001 to that in 2004?
Offer a very short reply. 1.07. What is the ratio of the Employment (as % of male employment) in Self-employed in 2001 to that in 2004?
Keep it short and to the point. 0.96. What is the ratio of the Employment (as % of male employment) of Agriculture in 2001 to that in 2005?
Offer a terse response. 1.19. What is the ratio of the Employment (as % of male employment) in Industry in 2001 to that in 2005?
Make the answer very short. 1.05. What is the ratio of the Employment (as % of male employment) of Services in 2001 to that in 2005?
Keep it short and to the point. 0.97. What is the ratio of the Employment (as % of male employment) of Self-employed in 2001 to that in 2005?
Keep it short and to the point. 0.98. What is the ratio of the Employment (as % of male employment) in Agriculture in 2001 to that in 2006?
Keep it short and to the point. 1.3. What is the ratio of the Employment (as % of male employment) in Industry in 2001 to that in 2006?
Ensure brevity in your answer.  1.09. What is the ratio of the Employment (as % of male employment) in Services in 2001 to that in 2006?
Give a very brief answer. 0.96. What is the ratio of the Employment (as % of male employment) of Self-employed in 2001 to that in 2006?
Your response must be concise. 0.95. What is the ratio of the Employment (as % of male employment) in Agriculture in 2001 to that in 2007?
Provide a succinct answer. 1.54. What is the ratio of the Employment (as % of male employment) in Industry in 2001 to that in 2007?
Offer a very short reply. 1.06. What is the ratio of the Employment (as % of male employment) in Services in 2001 to that in 2007?
Your response must be concise. 0.96. What is the ratio of the Employment (as % of male employment) of Self-employed in 2001 to that in 2007?
Offer a very short reply. 0.95. What is the ratio of the Employment (as % of male employment) in Agriculture in 2002 to that in 2003?
Your answer should be very brief. 1.11. What is the ratio of the Employment (as % of male employment) of Services in 2002 to that in 2003?
Offer a terse response. 0.99. What is the ratio of the Employment (as % of male employment) of Self-employed in 2002 to that in 2003?
Ensure brevity in your answer.  1.07. What is the ratio of the Employment (as % of male employment) in Agriculture in 2002 to that in 2004?
Give a very brief answer. 0.91. What is the ratio of the Employment (as % of male employment) of Industry in 2002 to that in 2004?
Make the answer very short. 0.85. What is the ratio of the Employment (as % of male employment) of Services in 2002 to that in 2004?
Your response must be concise. 1.08. What is the ratio of the Employment (as % of male employment) in Self-employed in 2002 to that in 2004?
Provide a short and direct response. 1.06. What is the ratio of the Employment (as % of male employment) in Industry in 2002 to that in 2005?
Offer a very short reply. 1.04. What is the ratio of the Employment (as % of male employment) of Services in 2002 to that in 2005?
Your answer should be very brief. 0.98. What is the ratio of the Employment (as % of male employment) in Self-employed in 2002 to that in 2005?
Give a very brief answer. 1.08. What is the ratio of the Employment (as % of male employment) in Agriculture in 2002 to that in 2006?
Make the answer very short. 1.27. What is the ratio of the Employment (as % of male employment) of Industry in 2002 to that in 2006?
Offer a very short reply. 1.09. What is the ratio of the Employment (as % of male employment) of Services in 2002 to that in 2006?
Your response must be concise. 0.97. What is the ratio of the Employment (as % of male employment) in Self-employed in 2002 to that in 2006?
Offer a terse response. 1.04. What is the ratio of the Employment (as % of male employment) in Industry in 2002 to that in 2007?
Your answer should be very brief. 1.05. What is the ratio of the Employment (as % of male employment) of Services in 2002 to that in 2007?
Your response must be concise. 0.96. What is the ratio of the Employment (as % of male employment) of Self-employed in 2002 to that in 2007?
Provide a succinct answer. 1.04. What is the ratio of the Employment (as % of male employment) in Agriculture in 2003 to that in 2004?
Provide a short and direct response. 0.83. What is the ratio of the Employment (as % of male employment) in Industry in 2003 to that in 2004?
Your answer should be very brief. 0.85. What is the ratio of the Employment (as % of male employment) in Services in 2003 to that in 2004?
Your answer should be very brief. 1.08. What is the ratio of the Employment (as % of male employment) of Self-employed in 2003 to that in 2004?
Ensure brevity in your answer.  0.99. What is the ratio of the Employment (as % of male employment) of Agriculture in 2003 to that in 2005?
Ensure brevity in your answer.  1.06. What is the ratio of the Employment (as % of male employment) of Industry in 2003 to that in 2005?
Provide a short and direct response. 1.04. What is the ratio of the Employment (as % of male employment) of Services in 2003 to that in 2005?
Your response must be concise. 0.98. What is the ratio of the Employment (as % of male employment) in Self-employed in 2003 to that in 2005?
Make the answer very short. 1.02. What is the ratio of the Employment (as % of male employment) in Agriculture in 2003 to that in 2006?
Your answer should be very brief. 1.15. What is the ratio of the Employment (as % of male employment) in Industry in 2003 to that in 2006?
Give a very brief answer. 1.08. What is the ratio of the Employment (as % of male employment) in Services in 2003 to that in 2006?
Ensure brevity in your answer.  0.97. What is the ratio of the Employment (as % of male employment) of Self-employed in 2003 to that in 2006?
Ensure brevity in your answer.  0.98. What is the ratio of the Employment (as % of male employment) of Agriculture in 2003 to that in 2007?
Make the answer very short. 1.36. What is the ratio of the Employment (as % of male employment) in Services in 2003 to that in 2007?
Keep it short and to the point. 0.97. What is the ratio of the Employment (as % of male employment) in Self-employed in 2003 to that in 2007?
Make the answer very short. 0.98. What is the ratio of the Employment (as % of male employment) of Agriculture in 2004 to that in 2005?
Provide a short and direct response. 1.28. What is the ratio of the Employment (as % of male employment) of Industry in 2004 to that in 2005?
Make the answer very short. 1.23. What is the ratio of the Employment (as % of male employment) of Services in 2004 to that in 2005?
Provide a succinct answer. 0.91. What is the ratio of the Employment (as % of male employment) of Self-employed in 2004 to that in 2005?
Provide a short and direct response. 1.02. What is the ratio of the Employment (as % of male employment) in Agriculture in 2004 to that in 2006?
Provide a succinct answer. 1.39. What is the ratio of the Employment (as % of male employment) in Industry in 2004 to that in 2006?
Make the answer very short. 1.28. What is the ratio of the Employment (as % of male employment) of Services in 2004 to that in 2006?
Provide a succinct answer. 0.9. What is the ratio of the Employment (as % of male employment) in Self-employed in 2004 to that in 2006?
Offer a very short reply. 0.98. What is the ratio of the Employment (as % of male employment) of Agriculture in 2004 to that in 2007?
Ensure brevity in your answer.  1.64. What is the ratio of the Employment (as % of male employment) in Industry in 2004 to that in 2007?
Your answer should be very brief. 1.24. What is the ratio of the Employment (as % of male employment) in Services in 2004 to that in 2007?
Your answer should be very brief. 0.9. What is the ratio of the Employment (as % of male employment) in Self-employed in 2004 to that in 2007?
Your answer should be compact. 0.98. What is the ratio of the Employment (as % of male employment) of Agriculture in 2005 to that in 2006?
Ensure brevity in your answer.  1.09. What is the ratio of the Employment (as % of male employment) in Industry in 2005 to that in 2006?
Ensure brevity in your answer.  1.04. What is the ratio of the Employment (as % of male employment) in Self-employed in 2005 to that in 2006?
Offer a very short reply. 0.96. What is the ratio of the Employment (as % of male employment) in Agriculture in 2005 to that in 2007?
Provide a succinct answer. 1.29. What is the ratio of the Employment (as % of male employment) of Industry in 2005 to that in 2007?
Your answer should be compact. 1.01. What is the ratio of the Employment (as % of male employment) in Services in 2005 to that in 2007?
Make the answer very short. 0.99. What is the ratio of the Employment (as % of male employment) in Self-employed in 2005 to that in 2007?
Offer a very short reply. 0.96. What is the ratio of the Employment (as % of male employment) of Agriculture in 2006 to that in 2007?
Ensure brevity in your answer.  1.18. What is the ratio of the Employment (as % of male employment) of Industry in 2006 to that in 2007?
Provide a succinct answer. 0.97. What is the ratio of the Employment (as % of male employment) in Services in 2006 to that in 2007?
Make the answer very short. 1. What is the ratio of the Employment (as % of male employment) of Self-employed in 2006 to that in 2007?
Give a very brief answer. 1. What is the difference between the highest and the second highest Employment (as % of male employment) in Agriculture?
Provide a succinct answer. 1.8. What is the difference between the highest and the second highest Employment (as % of male employment) of Industry?
Make the answer very short. 3.9. What is the difference between the highest and the second highest Employment (as % of male employment) of Services?
Your response must be concise. 0.2. 